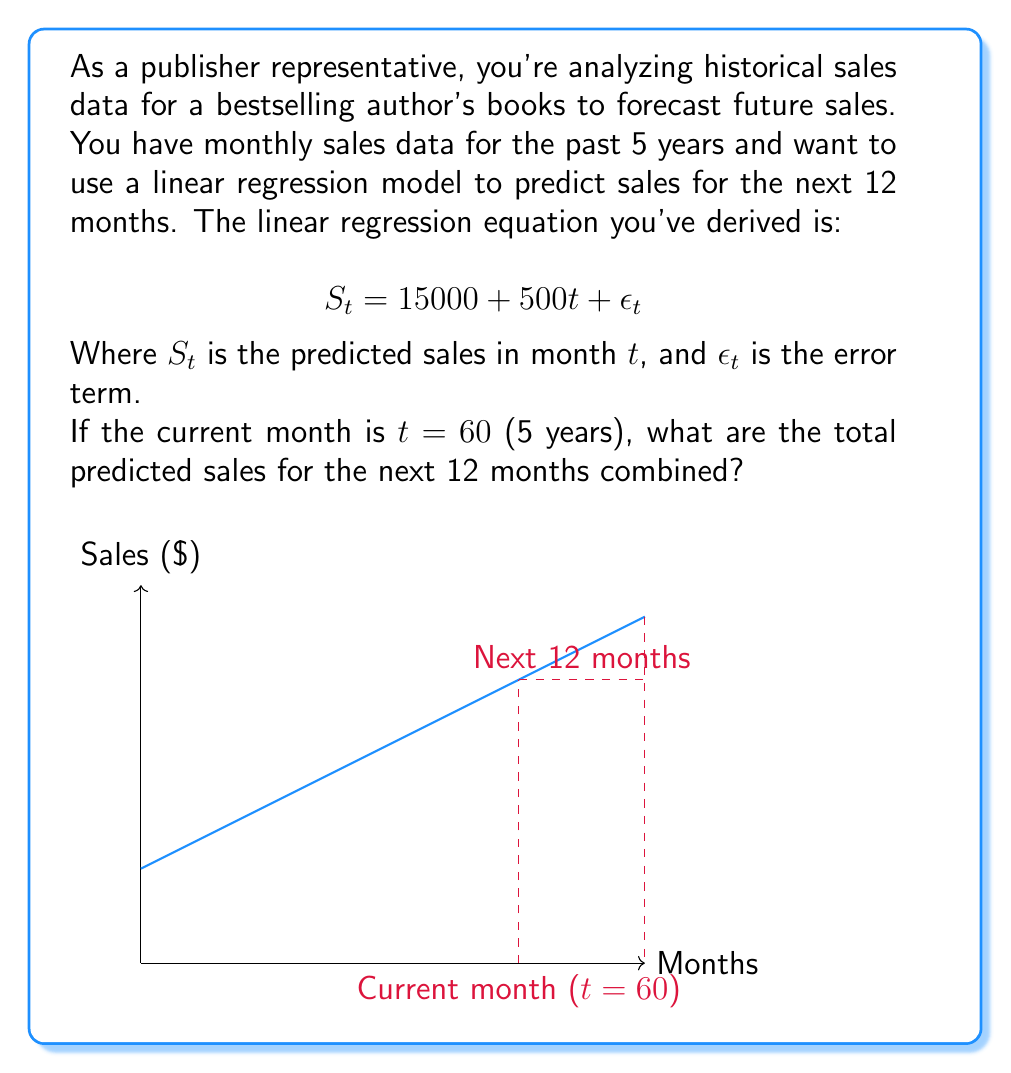Can you solve this math problem? Let's approach this step-by-step:

1) We need to calculate the sum of predicted sales from month 61 to month 72.

2) The general formula for each month is:
   $S_t = 15000 + 500t$

3) We need to sum this formula for t = 61 to 72:
   $\sum_{t=61}^{72} (15000 + 500t)$

4) This can be split into two sums:
   $\sum_{t=61}^{72} 15000 + \sum_{t=61}^{72} 500t$

5) The first sum is simply 15000 multiplied by 12:
   $12 \times 15000 = 180000$

6) The second sum is an arithmetic sequence. We can use the formula:
   $\sum_{t=a}^{b} t = \frac{n(a+b)}{2}$, where $n$ is the number of terms.

   Here, $a = 61$, $b = 72$, and $n = 12$

   $\sum_{t=61}^{72} t = \frac{12(61+72)}{2} = \frac{12 \times 133}{2} = 798$

7) Multiply this by 500:
   $500 \times 798 = 399000$

8) Sum the results from steps 5 and 7:
   $180000 + 399000 = 579000$

Therefore, the total predicted sales for the next 12 months is $579,000.
Answer: $579,000 